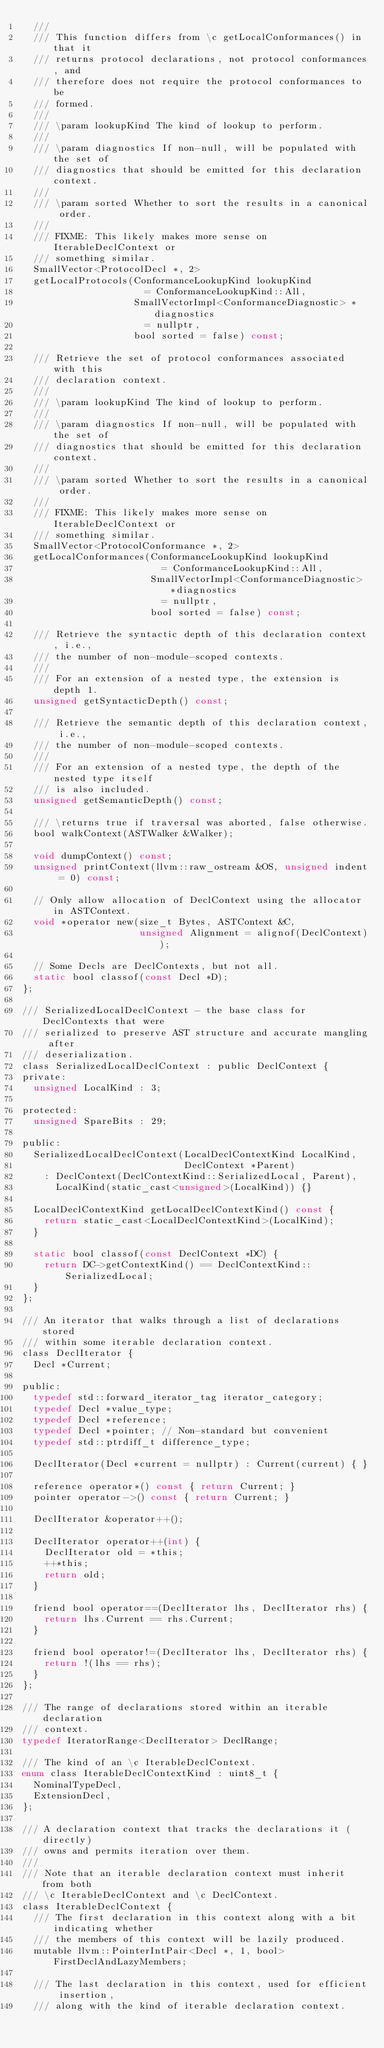Convert code to text. <code><loc_0><loc_0><loc_500><loc_500><_C_>  ///
  /// This function differs from \c getLocalConformances() in that it
  /// returns protocol declarations, not protocol conformances, and
  /// therefore does not require the protocol conformances to be
  /// formed.
  ///
  /// \param lookupKind The kind of lookup to perform.
  ///
  /// \param diagnostics If non-null, will be populated with the set of
  /// diagnostics that should be emitted for this declaration context.
  ///
  /// \param sorted Whether to sort the results in a canonical order.
  ///
  /// FIXME: This likely makes more sense on IterableDeclContext or
  /// something similar.
  SmallVector<ProtocolDecl *, 2>
  getLocalProtocols(ConformanceLookupKind lookupKind
                      = ConformanceLookupKind::All,
                    SmallVectorImpl<ConformanceDiagnostic> *diagnostics
                      = nullptr,
                    bool sorted = false) const;

  /// Retrieve the set of protocol conformances associated with this
  /// declaration context.
  ///
  /// \param lookupKind The kind of lookup to perform.
  ///
  /// \param diagnostics If non-null, will be populated with the set of
  /// diagnostics that should be emitted for this declaration context.
  ///
  /// \param sorted Whether to sort the results in a canonical order.
  ///
  /// FIXME: This likely makes more sense on IterableDeclContext or
  /// something similar.
  SmallVector<ProtocolConformance *, 2>
  getLocalConformances(ConformanceLookupKind lookupKind
                         = ConformanceLookupKind::All,
                       SmallVectorImpl<ConformanceDiagnostic> *diagnostics
                         = nullptr,
                       bool sorted = false) const;

  /// Retrieve the syntactic depth of this declaration context, i.e.,
  /// the number of non-module-scoped contexts.
  ///
  /// For an extension of a nested type, the extension is depth 1.
  unsigned getSyntacticDepth() const;

  /// Retrieve the semantic depth of this declaration context, i.e.,
  /// the number of non-module-scoped contexts.
  ///
  /// For an extension of a nested type, the depth of the nested type itself
  /// is also included.
  unsigned getSemanticDepth() const;

  /// \returns true if traversal was aborted, false otherwise.
  bool walkContext(ASTWalker &Walker);

  void dumpContext() const;
  unsigned printContext(llvm::raw_ostream &OS, unsigned indent = 0) const;

  // Only allow allocation of DeclContext using the allocator in ASTContext.
  void *operator new(size_t Bytes, ASTContext &C,
                     unsigned Alignment = alignof(DeclContext));
  
  // Some Decls are DeclContexts, but not all.
  static bool classof(const Decl *D);
};

/// SerializedLocalDeclContext - the base class for DeclContexts that were
/// serialized to preserve AST structure and accurate mangling after
/// deserialization.
class SerializedLocalDeclContext : public DeclContext {
private:
  unsigned LocalKind : 3;

protected:
  unsigned SpareBits : 29;

public:
  SerializedLocalDeclContext(LocalDeclContextKind LocalKind,
                             DeclContext *Parent)
    : DeclContext(DeclContextKind::SerializedLocal, Parent),
      LocalKind(static_cast<unsigned>(LocalKind)) {}

  LocalDeclContextKind getLocalDeclContextKind() const {
    return static_cast<LocalDeclContextKind>(LocalKind);
  }

  static bool classof(const DeclContext *DC) {
    return DC->getContextKind() == DeclContextKind::SerializedLocal;
  }
};

/// An iterator that walks through a list of declarations stored
/// within some iterable declaration context.
class DeclIterator {
  Decl *Current;

public: 
  typedef std::forward_iterator_tag iterator_category;
  typedef Decl *value_type;
  typedef Decl *reference;
  typedef Decl *pointer; // Non-standard but convenient
  typedef std::ptrdiff_t difference_type;

  DeclIterator(Decl *current = nullptr) : Current(current) { }

  reference operator*() const { return Current; }
  pointer operator->() const { return Current; }

  DeclIterator &operator++();

  DeclIterator operator++(int) {
    DeclIterator old = *this;
    ++*this;
    return old;
  }

  friend bool operator==(DeclIterator lhs, DeclIterator rhs) {
    return lhs.Current == rhs.Current; 
  }

  friend bool operator!=(DeclIterator lhs, DeclIterator rhs) {
    return !(lhs == rhs);
  }
};

/// The range of declarations stored within an iterable declaration
/// context.
typedef IteratorRange<DeclIterator> DeclRange;

/// The kind of an \c IterableDeclContext.
enum class IterableDeclContextKind : uint8_t {  
  NominalTypeDecl,
  ExtensionDecl,
};

/// A declaration context that tracks the declarations it (directly)
/// owns and permits iteration over them.
///
/// Note that an iterable declaration context must inherit from both
/// \c IterableDeclContext and \c DeclContext.
class IterableDeclContext {
  /// The first declaration in this context along with a bit indicating whether
  /// the members of this context will be lazily produced.
  mutable llvm::PointerIntPair<Decl *, 1, bool> FirstDeclAndLazyMembers;

  /// The last declaration in this context, used for efficient insertion,
  /// along with the kind of iterable declaration context.</code> 